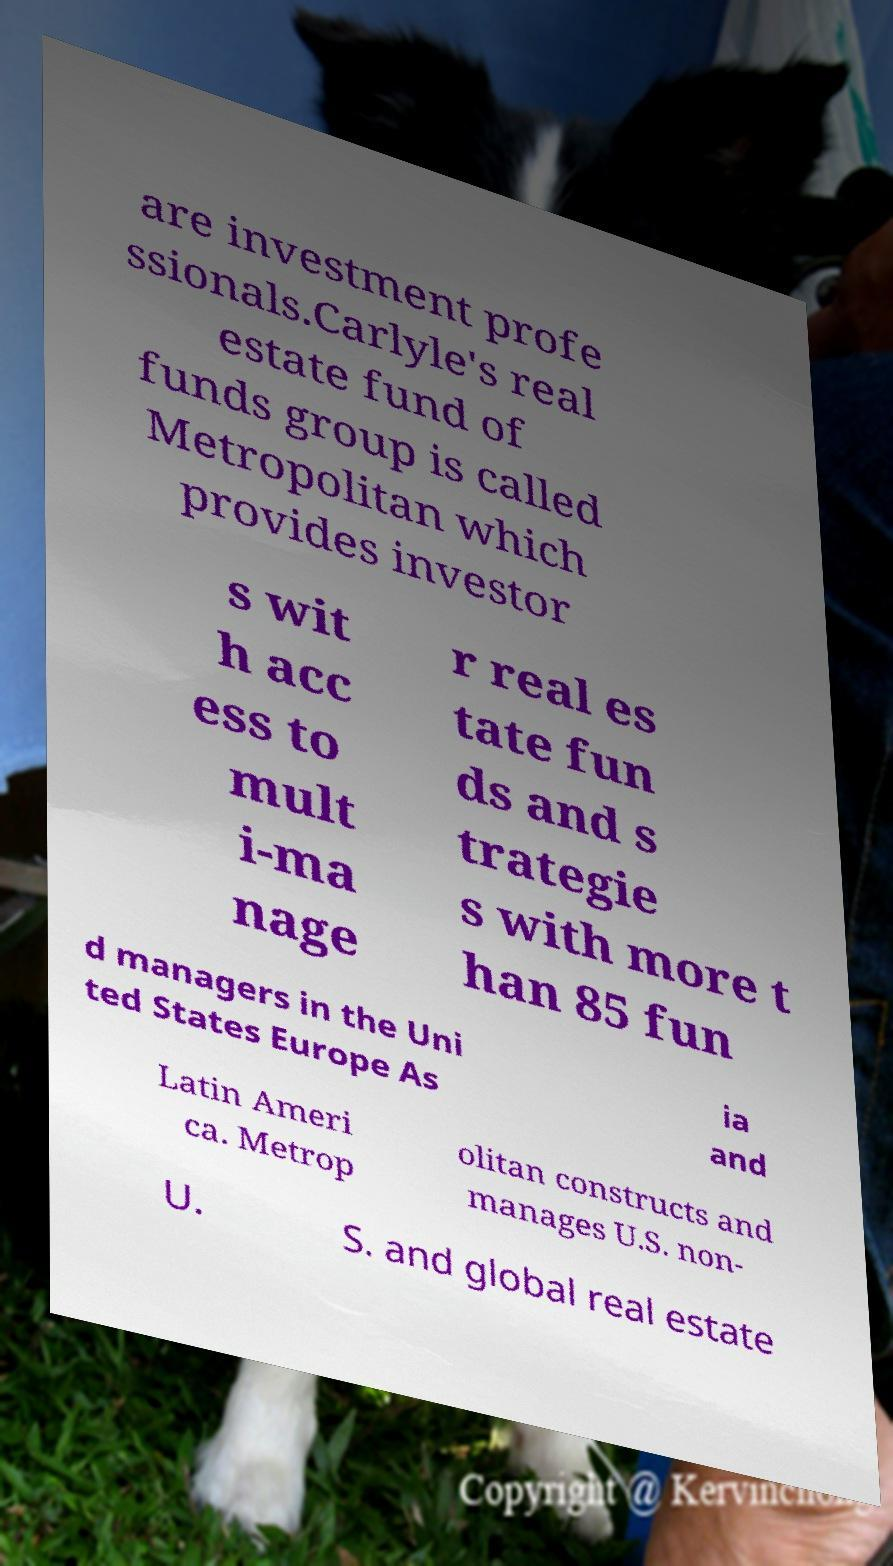Could you assist in decoding the text presented in this image and type it out clearly? are investment profe ssionals.Carlyle's real estate fund of funds group is called Metropolitan which provides investor s wit h acc ess to mult i-ma nage r real es tate fun ds and s trategie s with more t han 85 fun d managers in the Uni ted States Europe As ia and Latin Ameri ca. Metrop olitan constructs and manages U.S. non- U. S. and global real estate 